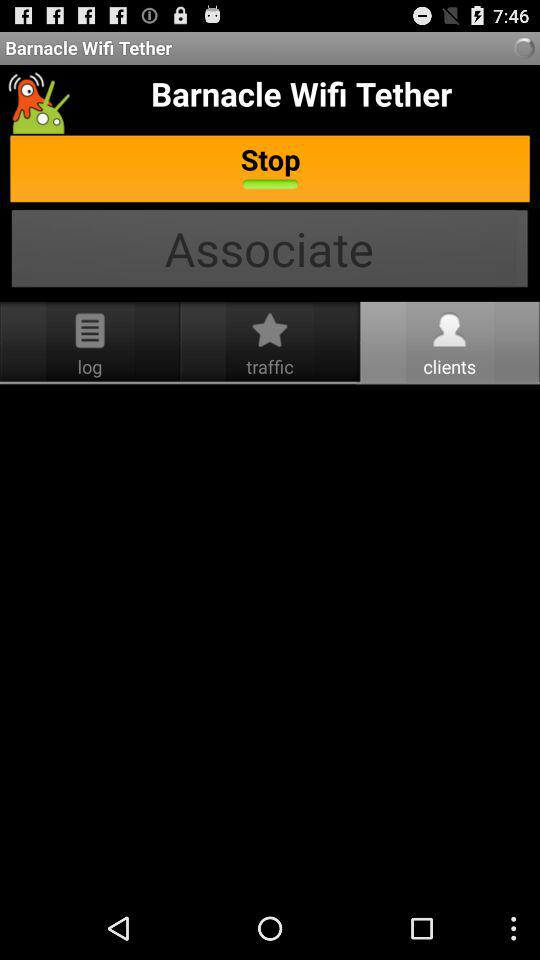Which tab is selected? The selected tab is "clients". 